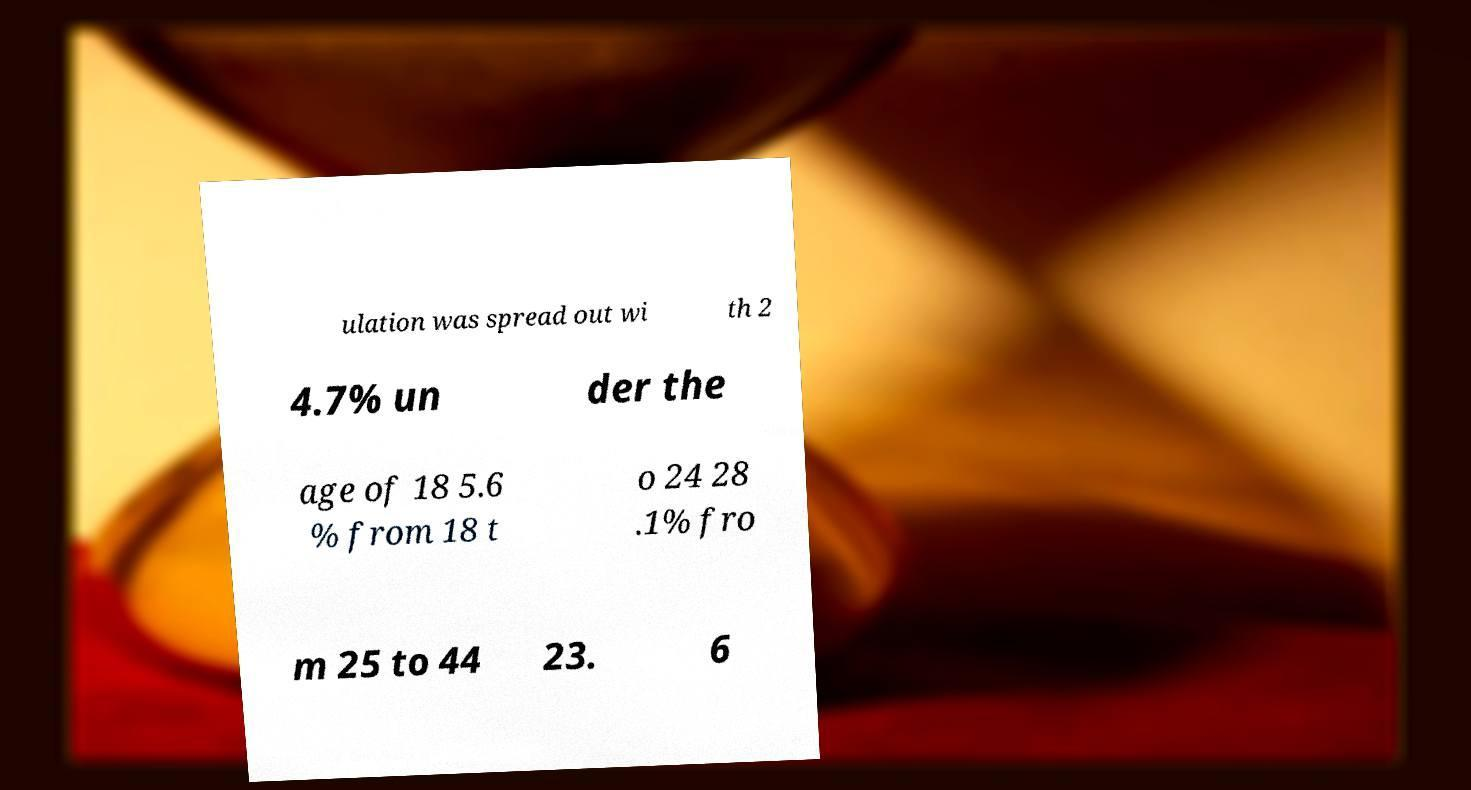Could you assist in decoding the text presented in this image and type it out clearly? ulation was spread out wi th 2 4.7% un der the age of 18 5.6 % from 18 t o 24 28 .1% fro m 25 to 44 23. 6 